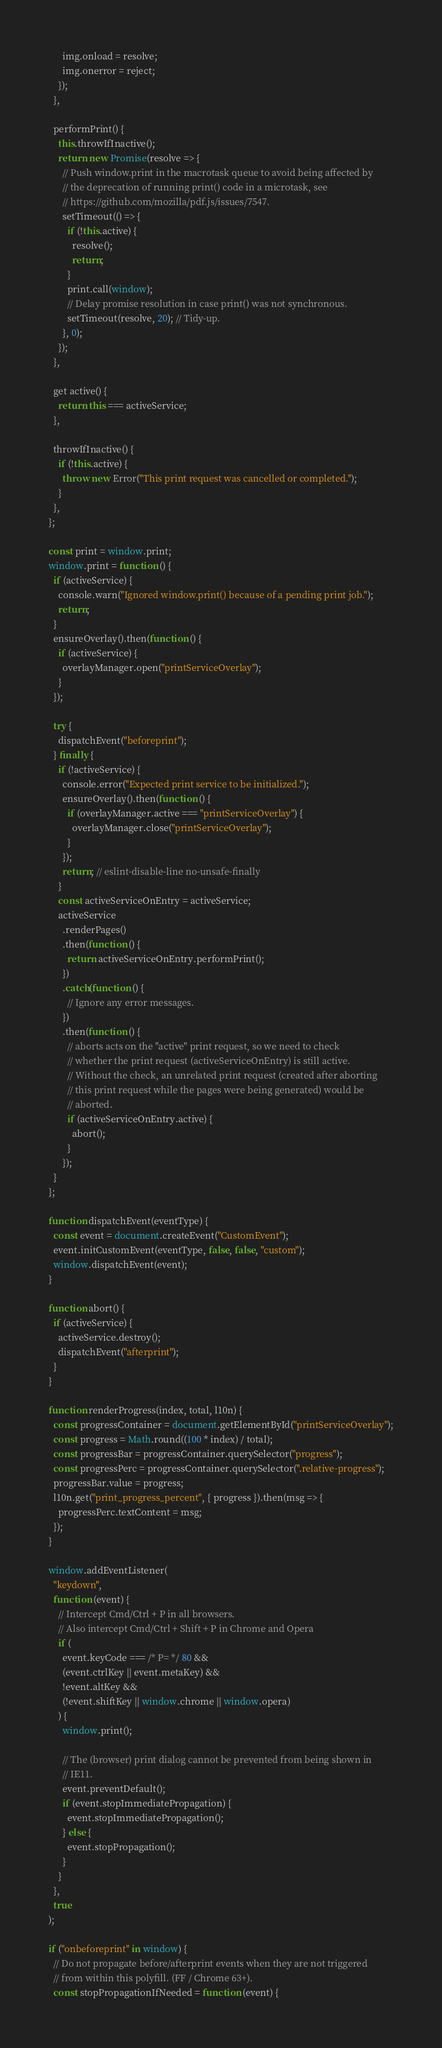<code> <loc_0><loc_0><loc_500><loc_500><_JavaScript_>      img.onload = resolve;
      img.onerror = reject;
    });
  },

  performPrint() {
    this.throwIfInactive();
    return new Promise(resolve => {
      // Push window.print in the macrotask queue to avoid being affected by
      // the deprecation of running print() code in a microtask, see
      // https://github.com/mozilla/pdf.js/issues/7547.
      setTimeout(() => {
        if (!this.active) {
          resolve();
          return;
        }
        print.call(window);
        // Delay promise resolution in case print() was not synchronous.
        setTimeout(resolve, 20); // Tidy-up.
      }, 0);
    });
  },

  get active() {
    return this === activeService;
  },

  throwIfInactive() {
    if (!this.active) {
      throw new Error("This print request was cancelled or completed.");
    }
  },
};

const print = window.print;
window.print = function () {
  if (activeService) {
    console.warn("Ignored window.print() because of a pending print job.");
    return;
  }
  ensureOverlay().then(function () {
    if (activeService) {
      overlayManager.open("printServiceOverlay");
    }
  });

  try {
    dispatchEvent("beforeprint");
  } finally {
    if (!activeService) {
      console.error("Expected print service to be initialized.");
      ensureOverlay().then(function () {
        if (overlayManager.active === "printServiceOverlay") {
          overlayManager.close("printServiceOverlay");
        }
      });
      return; // eslint-disable-line no-unsafe-finally
    }
    const activeServiceOnEntry = activeService;
    activeService
      .renderPages()
      .then(function () {
        return activeServiceOnEntry.performPrint();
      })
      .catch(function () {
        // Ignore any error messages.
      })
      .then(function () {
        // aborts acts on the "active" print request, so we need to check
        // whether the print request (activeServiceOnEntry) is still active.
        // Without the check, an unrelated print request (created after aborting
        // this print request while the pages were being generated) would be
        // aborted.
        if (activeServiceOnEntry.active) {
          abort();
        }
      });
  }
};

function dispatchEvent(eventType) {
  const event = document.createEvent("CustomEvent");
  event.initCustomEvent(eventType, false, false, "custom");
  window.dispatchEvent(event);
}

function abort() {
  if (activeService) {
    activeService.destroy();
    dispatchEvent("afterprint");
  }
}

function renderProgress(index, total, l10n) {
  const progressContainer = document.getElementById("printServiceOverlay");
  const progress = Math.round((100 * index) / total);
  const progressBar = progressContainer.querySelector("progress");
  const progressPerc = progressContainer.querySelector(".relative-progress");
  progressBar.value = progress;
  l10n.get("print_progress_percent", { progress }).then(msg => {
    progressPerc.textContent = msg;
  });
}

window.addEventListener(
  "keydown",
  function (event) {
    // Intercept Cmd/Ctrl + P in all browsers.
    // Also intercept Cmd/Ctrl + Shift + P in Chrome and Opera
    if (
      event.keyCode === /* P= */ 80 &&
      (event.ctrlKey || event.metaKey) &&
      !event.altKey &&
      (!event.shiftKey || window.chrome || window.opera)
    ) {
      window.print();

      // The (browser) print dialog cannot be prevented from being shown in
      // IE11.
      event.preventDefault();
      if (event.stopImmediatePropagation) {
        event.stopImmediatePropagation();
      } else {
        event.stopPropagation();
      }
    }
  },
  true
);

if ("onbeforeprint" in window) {
  // Do not propagate before/afterprint events when they are not triggered
  // from within this polyfill. (FF / Chrome 63+).
  const stopPropagationIfNeeded = function (event) {</code> 